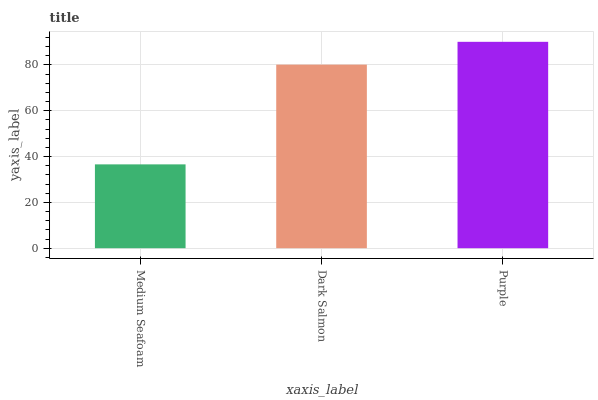Is Medium Seafoam the minimum?
Answer yes or no. Yes. Is Purple the maximum?
Answer yes or no. Yes. Is Dark Salmon the minimum?
Answer yes or no. No. Is Dark Salmon the maximum?
Answer yes or no. No. Is Dark Salmon greater than Medium Seafoam?
Answer yes or no. Yes. Is Medium Seafoam less than Dark Salmon?
Answer yes or no. Yes. Is Medium Seafoam greater than Dark Salmon?
Answer yes or no. No. Is Dark Salmon less than Medium Seafoam?
Answer yes or no. No. Is Dark Salmon the high median?
Answer yes or no. Yes. Is Dark Salmon the low median?
Answer yes or no. Yes. Is Purple the high median?
Answer yes or no. No. Is Medium Seafoam the low median?
Answer yes or no. No. 